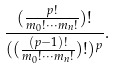Convert formula to latex. <formula><loc_0><loc_0><loc_500><loc_500>\frac { ( \frac { p ! } { m _ { 0 } ! \cdots m _ { n } ! } ) ! } { ( ( \frac { ( p - 1 ) ! } { m _ { 0 } ! \cdots m _ { n } ! } ) ! ) ^ { p } } .</formula> 